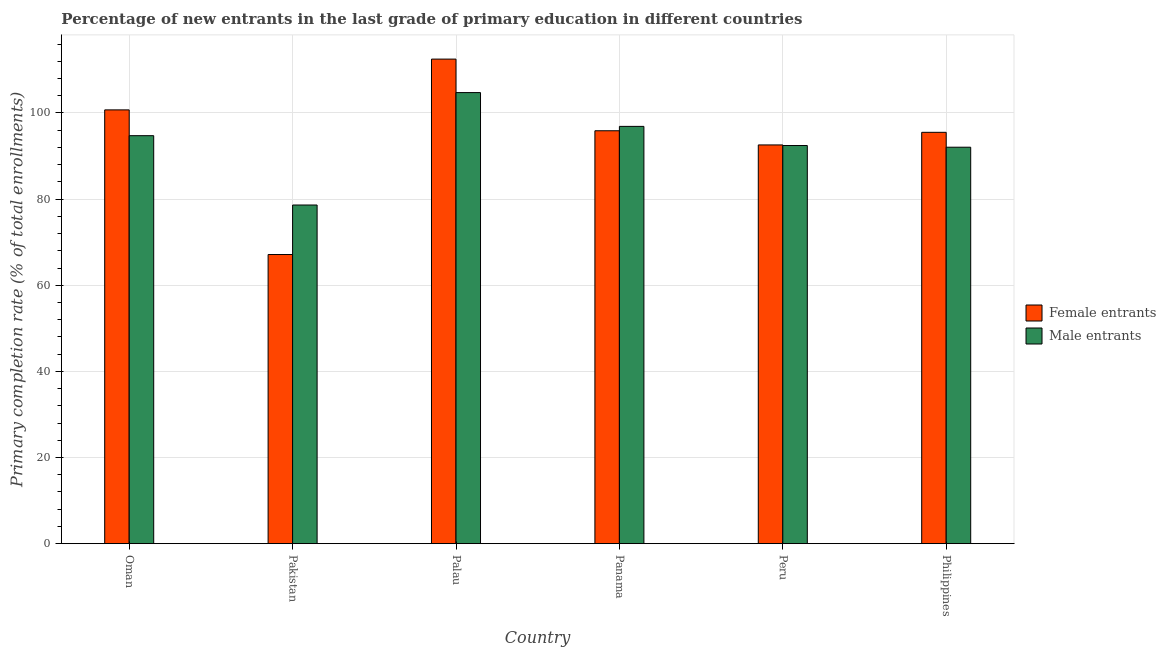How many different coloured bars are there?
Your answer should be very brief. 2. How many bars are there on the 6th tick from the right?
Offer a very short reply. 2. What is the label of the 6th group of bars from the left?
Your response must be concise. Philippines. What is the primary completion rate of male entrants in Oman?
Provide a succinct answer. 94.72. Across all countries, what is the maximum primary completion rate of female entrants?
Provide a succinct answer. 112.5. Across all countries, what is the minimum primary completion rate of male entrants?
Provide a succinct answer. 78.63. In which country was the primary completion rate of male entrants maximum?
Your answer should be compact. Palau. What is the total primary completion rate of male entrants in the graph?
Make the answer very short. 559.43. What is the difference between the primary completion rate of male entrants in Oman and that in Pakistan?
Your answer should be compact. 16.1. What is the difference between the primary completion rate of male entrants in Oman and the primary completion rate of female entrants in Pakistan?
Your response must be concise. 27.6. What is the average primary completion rate of female entrants per country?
Offer a very short reply. 94.05. What is the difference between the primary completion rate of male entrants and primary completion rate of female entrants in Palau?
Keep it short and to the point. -7.78. In how many countries, is the primary completion rate of male entrants greater than 80 %?
Offer a very short reply. 5. What is the ratio of the primary completion rate of female entrants in Oman to that in Philippines?
Provide a short and direct response. 1.05. What is the difference between the highest and the second highest primary completion rate of male entrants?
Offer a terse response. 7.85. What is the difference between the highest and the lowest primary completion rate of male entrants?
Provide a short and direct response. 26.1. In how many countries, is the primary completion rate of male entrants greater than the average primary completion rate of male entrants taken over all countries?
Keep it short and to the point. 3. Is the sum of the primary completion rate of male entrants in Peru and Philippines greater than the maximum primary completion rate of female entrants across all countries?
Make the answer very short. Yes. What does the 2nd bar from the left in Panama represents?
Keep it short and to the point. Male entrants. What does the 1st bar from the right in Palau represents?
Ensure brevity in your answer.  Male entrants. What is the difference between two consecutive major ticks on the Y-axis?
Ensure brevity in your answer.  20. Are the values on the major ticks of Y-axis written in scientific E-notation?
Keep it short and to the point. No. Does the graph contain grids?
Your answer should be compact. Yes. Where does the legend appear in the graph?
Give a very brief answer. Center right. How are the legend labels stacked?
Provide a succinct answer. Vertical. What is the title of the graph?
Your answer should be compact. Percentage of new entrants in the last grade of primary education in different countries. Does "International Visitors" appear as one of the legend labels in the graph?
Provide a short and direct response. No. What is the label or title of the X-axis?
Keep it short and to the point. Country. What is the label or title of the Y-axis?
Provide a short and direct response. Primary completion rate (% of total enrollments). What is the Primary completion rate (% of total enrollments) of Female entrants in Oman?
Keep it short and to the point. 100.71. What is the Primary completion rate (% of total enrollments) of Male entrants in Oman?
Ensure brevity in your answer.  94.72. What is the Primary completion rate (% of total enrollments) of Female entrants in Pakistan?
Offer a terse response. 67.13. What is the Primary completion rate (% of total enrollments) of Male entrants in Pakistan?
Provide a short and direct response. 78.63. What is the Primary completion rate (% of total enrollments) in Female entrants in Palau?
Make the answer very short. 112.5. What is the Primary completion rate (% of total enrollments) in Male entrants in Palau?
Give a very brief answer. 104.72. What is the Primary completion rate (% of total enrollments) in Female entrants in Panama?
Ensure brevity in your answer.  95.86. What is the Primary completion rate (% of total enrollments) in Male entrants in Panama?
Ensure brevity in your answer.  96.88. What is the Primary completion rate (% of total enrollments) of Female entrants in Peru?
Offer a very short reply. 92.57. What is the Primary completion rate (% of total enrollments) of Male entrants in Peru?
Give a very brief answer. 92.44. What is the Primary completion rate (% of total enrollments) in Female entrants in Philippines?
Offer a terse response. 95.5. What is the Primary completion rate (% of total enrollments) in Male entrants in Philippines?
Give a very brief answer. 92.04. Across all countries, what is the maximum Primary completion rate (% of total enrollments) of Female entrants?
Give a very brief answer. 112.5. Across all countries, what is the maximum Primary completion rate (% of total enrollments) in Male entrants?
Keep it short and to the point. 104.72. Across all countries, what is the minimum Primary completion rate (% of total enrollments) of Female entrants?
Make the answer very short. 67.13. Across all countries, what is the minimum Primary completion rate (% of total enrollments) of Male entrants?
Your answer should be compact. 78.63. What is the total Primary completion rate (% of total enrollments) of Female entrants in the graph?
Provide a short and direct response. 564.27. What is the total Primary completion rate (% of total enrollments) in Male entrants in the graph?
Provide a short and direct response. 559.43. What is the difference between the Primary completion rate (% of total enrollments) of Female entrants in Oman and that in Pakistan?
Offer a terse response. 33.58. What is the difference between the Primary completion rate (% of total enrollments) of Male entrants in Oman and that in Pakistan?
Keep it short and to the point. 16.1. What is the difference between the Primary completion rate (% of total enrollments) of Female entrants in Oman and that in Palau?
Make the answer very short. -11.79. What is the difference between the Primary completion rate (% of total enrollments) of Male entrants in Oman and that in Palau?
Ensure brevity in your answer.  -10. What is the difference between the Primary completion rate (% of total enrollments) in Female entrants in Oman and that in Panama?
Your response must be concise. 4.85. What is the difference between the Primary completion rate (% of total enrollments) in Male entrants in Oman and that in Panama?
Offer a very short reply. -2.16. What is the difference between the Primary completion rate (% of total enrollments) of Female entrants in Oman and that in Peru?
Offer a terse response. 8.14. What is the difference between the Primary completion rate (% of total enrollments) in Male entrants in Oman and that in Peru?
Provide a short and direct response. 2.29. What is the difference between the Primary completion rate (% of total enrollments) in Female entrants in Oman and that in Philippines?
Your answer should be compact. 5.21. What is the difference between the Primary completion rate (% of total enrollments) in Male entrants in Oman and that in Philippines?
Provide a short and direct response. 2.68. What is the difference between the Primary completion rate (% of total enrollments) of Female entrants in Pakistan and that in Palau?
Make the answer very short. -45.37. What is the difference between the Primary completion rate (% of total enrollments) in Male entrants in Pakistan and that in Palau?
Make the answer very short. -26.1. What is the difference between the Primary completion rate (% of total enrollments) of Female entrants in Pakistan and that in Panama?
Ensure brevity in your answer.  -28.73. What is the difference between the Primary completion rate (% of total enrollments) of Male entrants in Pakistan and that in Panama?
Offer a very short reply. -18.25. What is the difference between the Primary completion rate (% of total enrollments) of Female entrants in Pakistan and that in Peru?
Keep it short and to the point. -25.45. What is the difference between the Primary completion rate (% of total enrollments) of Male entrants in Pakistan and that in Peru?
Give a very brief answer. -13.81. What is the difference between the Primary completion rate (% of total enrollments) of Female entrants in Pakistan and that in Philippines?
Keep it short and to the point. -28.37. What is the difference between the Primary completion rate (% of total enrollments) in Male entrants in Pakistan and that in Philippines?
Your response must be concise. -13.42. What is the difference between the Primary completion rate (% of total enrollments) in Female entrants in Palau and that in Panama?
Provide a succinct answer. 16.64. What is the difference between the Primary completion rate (% of total enrollments) in Male entrants in Palau and that in Panama?
Your answer should be compact. 7.85. What is the difference between the Primary completion rate (% of total enrollments) in Female entrants in Palau and that in Peru?
Provide a succinct answer. 19.93. What is the difference between the Primary completion rate (% of total enrollments) of Male entrants in Palau and that in Peru?
Give a very brief answer. 12.29. What is the difference between the Primary completion rate (% of total enrollments) of Female entrants in Palau and that in Philippines?
Provide a short and direct response. 17. What is the difference between the Primary completion rate (% of total enrollments) in Male entrants in Palau and that in Philippines?
Keep it short and to the point. 12.68. What is the difference between the Primary completion rate (% of total enrollments) of Female entrants in Panama and that in Peru?
Offer a terse response. 3.29. What is the difference between the Primary completion rate (% of total enrollments) in Male entrants in Panama and that in Peru?
Make the answer very short. 4.44. What is the difference between the Primary completion rate (% of total enrollments) of Female entrants in Panama and that in Philippines?
Provide a succinct answer. 0.36. What is the difference between the Primary completion rate (% of total enrollments) of Male entrants in Panama and that in Philippines?
Give a very brief answer. 4.84. What is the difference between the Primary completion rate (% of total enrollments) of Female entrants in Peru and that in Philippines?
Offer a terse response. -2.93. What is the difference between the Primary completion rate (% of total enrollments) in Male entrants in Peru and that in Philippines?
Keep it short and to the point. 0.39. What is the difference between the Primary completion rate (% of total enrollments) of Female entrants in Oman and the Primary completion rate (% of total enrollments) of Male entrants in Pakistan?
Your answer should be very brief. 22.08. What is the difference between the Primary completion rate (% of total enrollments) of Female entrants in Oman and the Primary completion rate (% of total enrollments) of Male entrants in Palau?
Ensure brevity in your answer.  -4.02. What is the difference between the Primary completion rate (% of total enrollments) in Female entrants in Oman and the Primary completion rate (% of total enrollments) in Male entrants in Panama?
Your answer should be compact. 3.83. What is the difference between the Primary completion rate (% of total enrollments) in Female entrants in Oman and the Primary completion rate (% of total enrollments) in Male entrants in Peru?
Your answer should be very brief. 8.27. What is the difference between the Primary completion rate (% of total enrollments) in Female entrants in Oman and the Primary completion rate (% of total enrollments) in Male entrants in Philippines?
Your response must be concise. 8.67. What is the difference between the Primary completion rate (% of total enrollments) in Female entrants in Pakistan and the Primary completion rate (% of total enrollments) in Male entrants in Palau?
Your response must be concise. -37.6. What is the difference between the Primary completion rate (% of total enrollments) in Female entrants in Pakistan and the Primary completion rate (% of total enrollments) in Male entrants in Panama?
Offer a terse response. -29.75. What is the difference between the Primary completion rate (% of total enrollments) in Female entrants in Pakistan and the Primary completion rate (% of total enrollments) in Male entrants in Peru?
Your answer should be compact. -25.31. What is the difference between the Primary completion rate (% of total enrollments) of Female entrants in Pakistan and the Primary completion rate (% of total enrollments) of Male entrants in Philippines?
Make the answer very short. -24.91. What is the difference between the Primary completion rate (% of total enrollments) of Female entrants in Palau and the Primary completion rate (% of total enrollments) of Male entrants in Panama?
Your response must be concise. 15.62. What is the difference between the Primary completion rate (% of total enrollments) of Female entrants in Palau and the Primary completion rate (% of total enrollments) of Male entrants in Peru?
Your answer should be very brief. 20.06. What is the difference between the Primary completion rate (% of total enrollments) of Female entrants in Palau and the Primary completion rate (% of total enrollments) of Male entrants in Philippines?
Offer a terse response. 20.46. What is the difference between the Primary completion rate (% of total enrollments) in Female entrants in Panama and the Primary completion rate (% of total enrollments) in Male entrants in Peru?
Make the answer very short. 3.43. What is the difference between the Primary completion rate (% of total enrollments) of Female entrants in Panama and the Primary completion rate (% of total enrollments) of Male entrants in Philippines?
Offer a very short reply. 3.82. What is the difference between the Primary completion rate (% of total enrollments) of Female entrants in Peru and the Primary completion rate (% of total enrollments) of Male entrants in Philippines?
Give a very brief answer. 0.53. What is the average Primary completion rate (% of total enrollments) in Female entrants per country?
Offer a terse response. 94.05. What is the average Primary completion rate (% of total enrollments) of Male entrants per country?
Provide a succinct answer. 93.24. What is the difference between the Primary completion rate (% of total enrollments) of Female entrants and Primary completion rate (% of total enrollments) of Male entrants in Oman?
Provide a short and direct response. 5.99. What is the difference between the Primary completion rate (% of total enrollments) in Female entrants and Primary completion rate (% of total enrollments) in Male entrants in Pakistan?
Provide a short and direct response. -11.5. What is the difference between the Primary completion rate (% of total enrollments) of Female entrants and Primary completion rate (% of total enrollments) of Male entrants in Palau?
Provide a short and direct response. 7.78. What is the difference between the Primary completion rate (% of total enrollments) of Female entrants and Primary completion rate (% of total enrollments) of Male entrants in Panama?
Keep it short and to the point. -1.02. What is the difference between the Primary completion rate (% of total enrollments) in Female entrants and Primary completion rate (% of total enrollments) in Male entrants in Peru?
Offer a terse response. 0.14. What is the difference between the Primary completion rate (% of total enrollments) in Female entrants and Primary completion rate (% of total enrollments) in Male entrants in Philippines?
Your answer should be compact. 3.46. What is the ratio of the Primary completion rate (% of total enrollments) in Female entrants in Oman to that in Pakistan?
Your response must be concise. 1.5. What is the ratio of the Primary completion rate (% of total enrollments) of Male entrants in Oman to that in Pakistan?
Your response must be concise. 1.2. What is the ratio of the Primary completion rate (% of total enrollments) in Female entrants in Oman to that in Palau?
Keep it short and to the point. 0.9. What is the ratio of the Primary completion rate (% of total enrollments) in Male entrants in Oman to that in Palau?
Provide a succinct answer. 0.9. What is the ratio of the Primary completion rate (% of total enrollments) of Female entrants in Oman to that in Panama?
Give a very brief answer. 1.05. What is the ratio of the Primary completion rate (% of total enrollments) of Male entrants in Oman to that in Panama?
Your answer should be very brief. 0.98. What is the ratio of the Primary completion rate (% of total enrollments) of Female entrants in Oman to that in Peru?
Your response must be concise. 1.09. What is the ratio of the Primary completion rate (% of total enrollments) in Male entrants in Oman to that in Peru?
Offer a very short reply. 1.02. What is the ratio of the Primary completion rate (% of total enrollments) of Female entrants in Oman to that in Philippines?
Offer a very short reply. 1.05. What is the ratio of the Primary completion rate (% of total enrollments) of Male entrants in Oman to that in Philippines?
Keep it short and to the point. 1.03. What is the ratio of the Primary completion rate (% of total enrollments) in Female entrants in Pakistan to that in Palau?
Make the answer very short. 0.6. What is the ratio of the Primary completion rate (% of total enrollments) of Male entrants in Pakistan to that in Palau?
Give a very brief answer. 0.75. What is the ratio of the Primary completion rate (% of total enrollments) of Female entrants in Pakistan to that in Panama?
Give a very brief answer. 0.7. What is the ratio of the Primary completion rate (% of total enrollments) in Male entrants in Pakistan to that in Panama?
Offer a very short reply. 0.81. What is the ratio of the Primary completion rate (% of total enrollments) in Female entrants in Pakistan to that in Peru?
Your answer should be very brief. 0.73. What is the ratio of the Primary completion rate (% of total enrollments) of Male entrants in Pakistan to that in Peru?
Make the answer very short. 0.85. What is the ratio of the Primary completion rate (% of total enrollments) of Female entrants in Pakistan to that in Philippines?
Make the answer very short. 0.7. What is the ratio of the Primary completion rate (% of total enrollments) of Male entrants in Pakistan to that in Philippines?
Ensure brevity in your answer.  0.85. What is the ratio of the Primary completion rate (% of total enrollments) in Female entrants in Palau to that in Panama?
Provide a succinct answer. 1.17. What is the ratio of the Primary completion rate (% of total enrollments) in Male entrants in Palau to that in Panama?
Your answer should be very brief. 1.08. What is the ratio of the Primary completion rate (% of total enrollments) of Female entrants in Palau to that in Peru?
Offer a terse response. 1.22. What is the ratio of the Primary completion rate (% of total enrollments) in Male entrants in Palau to that in Peru?
Offer a very short reply. 1.13. What is the ratio of the Primary completion rate (% of total enrollments) in Female entrants in Palau to that in Philippines?
Provide a short and direct response. 1.18. What is the ratio of the Primary completion rate (% of total enrollments) in Male entrants in Palau to that in Philippines?
Your response must be concise. 1.14. What is the ratio of the Primary completion rate (% of total enrollments) in Female entrants in Panama to that in Peru?
Your answer should be very brief. 1.04. What is the ratio of the Primary completion rate (% of total enrollments) in Male entrants in Panama to that in Peru?
Make the answer very short. 1.05. What is the ratio of the Primary completion rate (% of total enrollments) of Female entrants in Panama to that in Philippines?
Keep it short and to the point. 1. What is the ratio of the Primary completion rate (% of total enrollments) of Male entrants in Panama to that in Philippines?
Provide a short and direct response. 1.05. What is the ratio of the Primary completion rate (% of total enrollments) of Female entrants in Peru to that in Philippines?
Provide a succinct answer. 0.97. What is the difference between the highest and the second highest Primary completion rate (% of total enrollments) of Female entrants?
Offer a terse response. 11.79. What is the difference between the highest and the second highest Primary completion rate (% of total enrollments) in Male entrants?
Give a very brief answer. 7.85. What is the difference between the highest and the lowest Primary completion rate (% of total enrollments) in Female entrants?
Make the answer very short. 45.37. What is the difference between the highest and the lowest Primary completion rate (% of total enrollments) in Male entrants?
Provide a succinct answer. 26.1. 